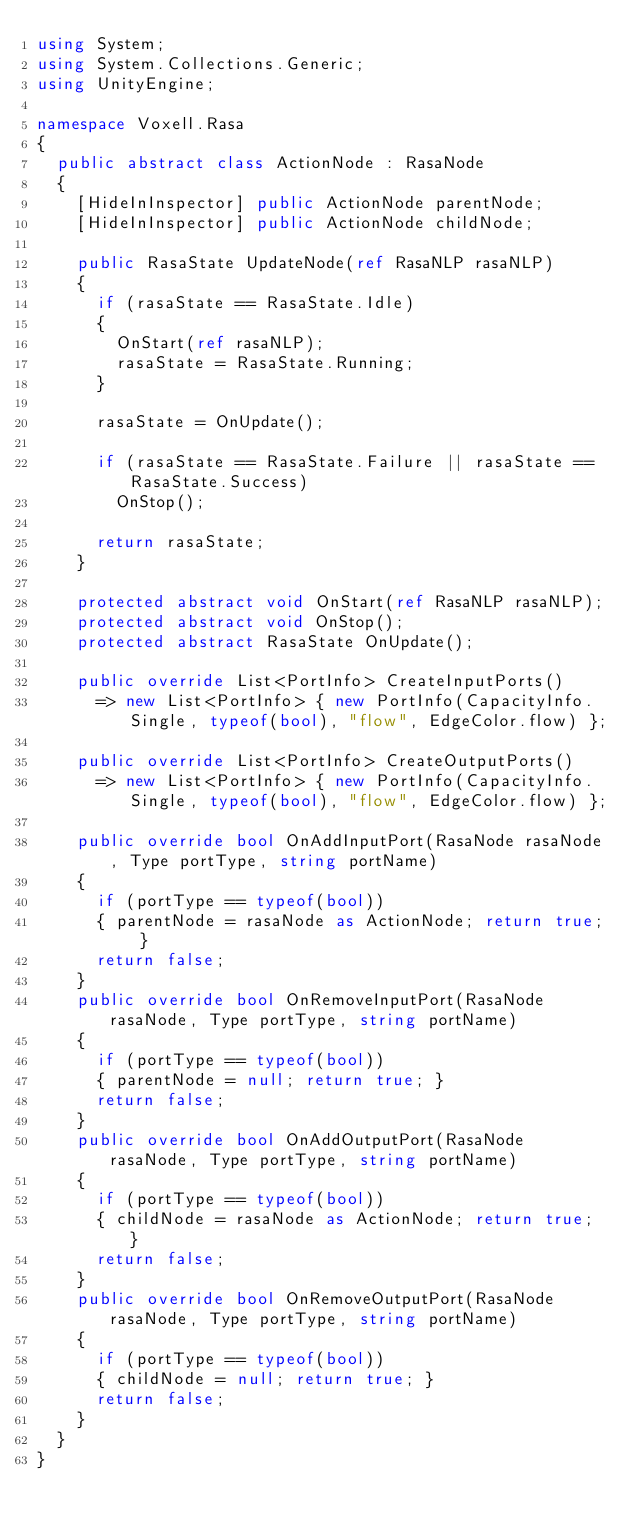<code> <loc_0><loc_0><loc_500><loc_500><_C#_>using System;
using System.Collections.Generic;
using UnityEngine;

namespace Voxell.Rasa
{
  public abstract class ActionNode : RasaNode
  {
    [HideInInspector] public ActionNode parentNode;
    [HideInInspector] public ActionNode childNode;

    public RasaState UpdateNode(ref RasaNLP rasaNLP)
    {
      if (rasaState == RasaState.Idle)
      {
        OnStart(ref rasaNLP);
        rasaState = RasaState.Running;
      }

      rasaState = OnUpdate();

      if (rasaState == RasaState.Failure || rasaState == RasaState.Success)
        OnStop();

      return rasaState;
    }

    protected abstract void OnStart(ref RasaNLP rasaNLP);
    protected abstract void OnStop();
    protected abstract RasaState OnUpdate();

    public override List<PortInfo> CreateInputPorts()
      => new List<PortInfo> { new PortInfo(CapacityInfo.Single, typeof(bool), "flow", EdgeColor.flow) };

    public override List<PortInfo> CreateOutputPorts()
      => new List<PortInfo> { new PortInfo(CapacityInfo.Single, typeof(bool), "flow", EdgeColor.flow) };

    public override bool OnAddInputPort(RasaNode rasaNode, Type portType, string portName)
    {
      if (portType == typeof(bool))
      { parentNode = rasaNode as ActionNode; return true; }
      return false;
    }
    public override bool OnRemoveInputPort(RasaNode rasaNode, Type portType, string portName)
    {
      if (portType == typeof(bool))
      { parentNode = null; return true; }
      return false;
    }
    public override bool OnAddOutputPort(RasaNode rasaNode, Type portType, string portName)
    {
      if (portType == typeof(bool))
      { childNode = rasaNode as ActionNode; return true; }
      return false;
    }
    public override bool OnRemoveOutputPort(RasaNode rasaNode, Type portType, string portName)
    {
      if (portType == typeof(bool))
      { childNode = null; return true; }
      return false;
    }
  }
}
</code> 